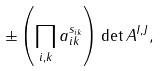<formula> <loc_0><loc_0><loc_500><loc_500>\pm \left ( \prod _ { i , k } a _ { i k } ^ { s _ { i k } } \right ) \det A ^ { I , J } ,</formula> 